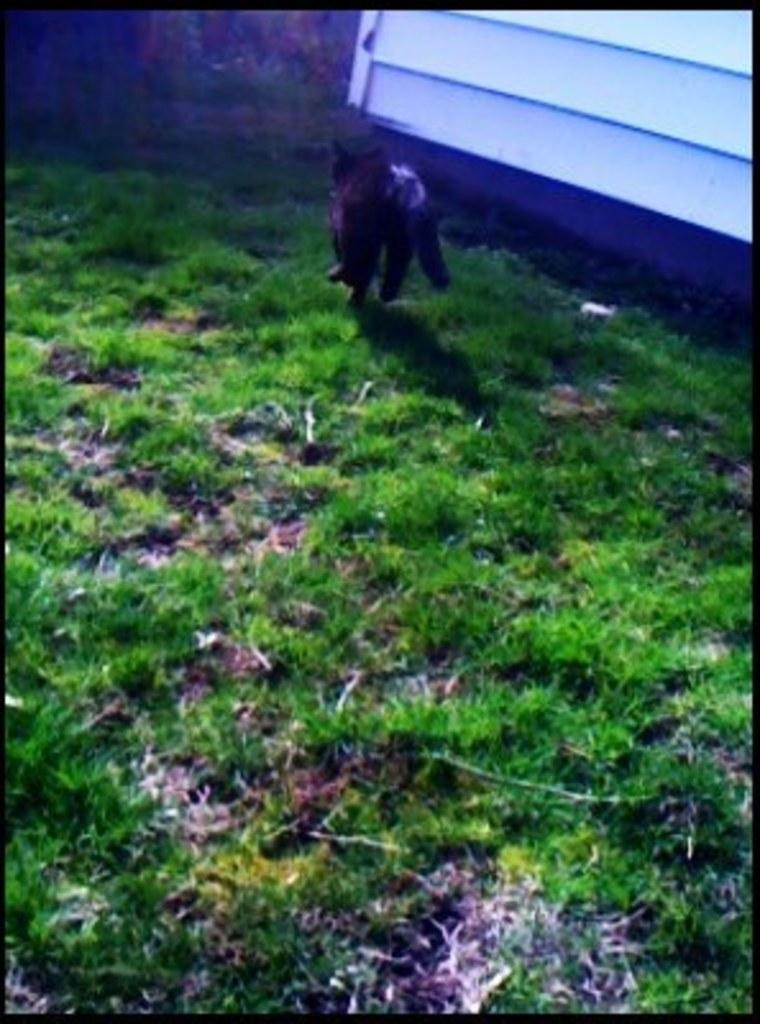What type of vegetation is present in the image? There is grass in the image. What else can be seen on the grass in the image? There is an animal on the grass in the image. What direction is the wren facing in the image? There is no wren present in the image; it only mentions an animal on the grass. 